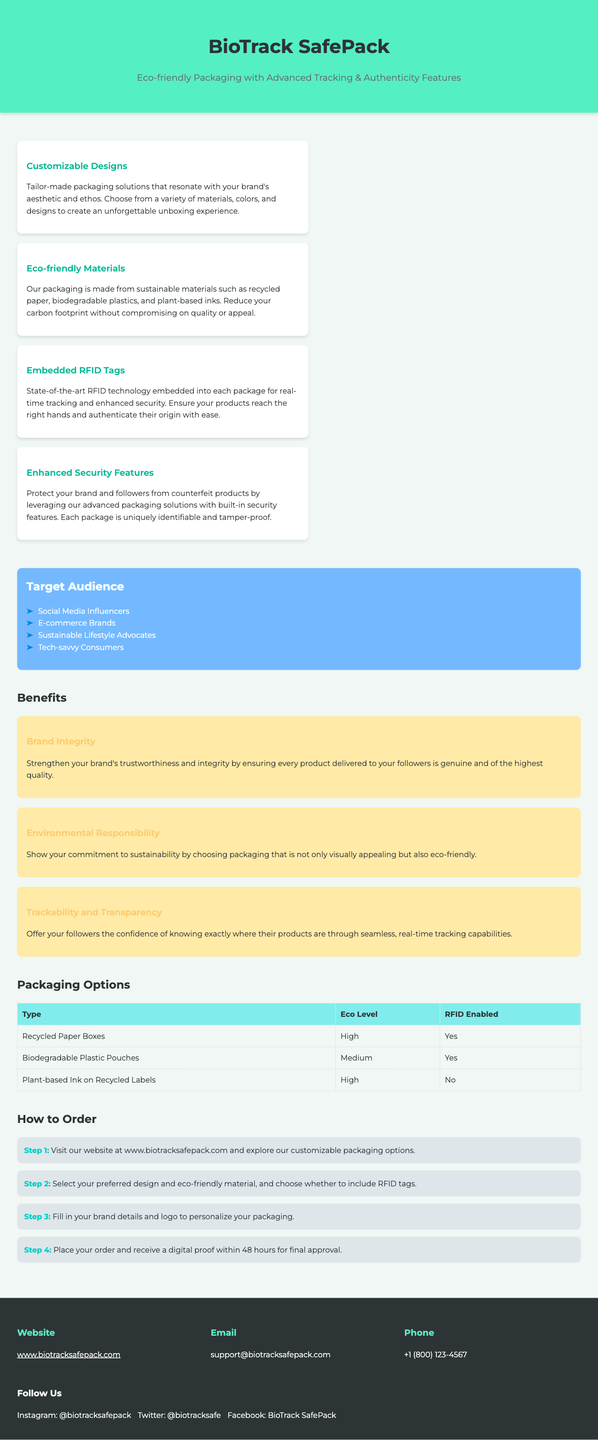What is the brand name of the packaging? The brand name is displayed prominently at the top of the document.
Answer: BioTrack SafePack What type of materials are used for packing? The document specifies that sustainable materials include recycled paper and biodegradable plastics.
Answer: Eco-friendly materials Which feature ensures product authenticity? The document mentions a specific technology for tracking and authenticating products.
Answer: Embedded RFID Tags How many steps are in the ordering process? The number of steps for the ordering process is directly mentioned in the section on how to order.
Answer: Four steps Who is the target audience mentioned? A list of specific target audiences is provided, including social media influencers.
Answer: Social Media Influencers What is the eco level of Recycled Paper Boxes? The eco level for this packaging option is stated in the packaging options table.
Answer: High What is required to personalize packaging? The process includes detailing specific information needed for branding.
Answer: Brand details and logo What is the contact email for support? The contact information section provides a direct email for customer inquiries.
Answer: support@biotracksafepack.com Which design feature enhances security? The document mentions a particular feature that provides security against counterfeiting.
Answer: Enhanced Security Features 